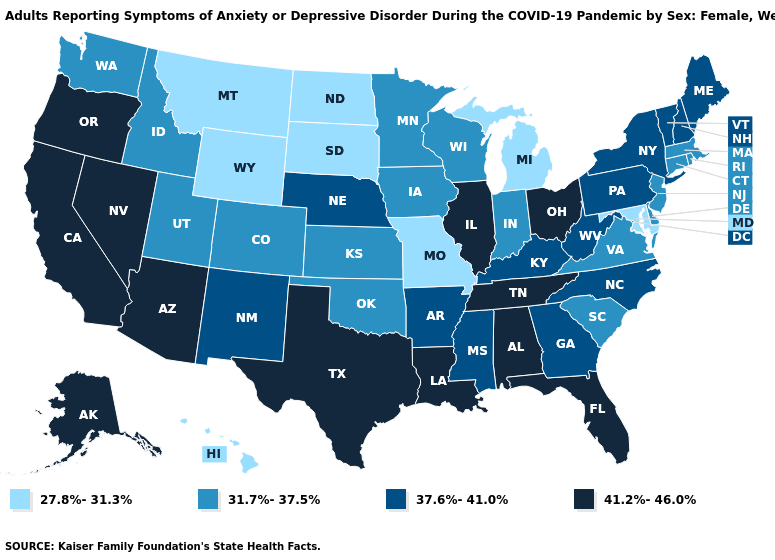Does the first symbol in the legend represent the smallest category?
Be succinct. Yes. Name the states that have a value in the range 41.2%-46.0%?
Short answer required. Alabama, Alaska, Arizona, California, Florida, Illinois, Louisiana, Nevada, Ohio, Oregon, Tennessee, Texas. Name the states that have a value in the range 27.8%-31.3%?
Give a very brief answer. Hawaii, Maryland, Michigan, Missouri, Montana, North Dakota, South Dakota, Wyoming. Which states have the lowest value in the USA?
Give a very brief answer. Hawaii, Maryland, Michigan, Missouri, Montana, North Dakota, South Dakota, Wyoming. What is the value of Illinois?
Keep it brief. 41.2%-46.0%. Name the states that have a value in the range 31.7%-37.5%?
Answer briefly. Colorado, Connecticut, Delaware, Idaho, Indiana, Iowa, Kansas, Massachusetts, Minnesota, New Jersey, Oklahoma, Rhode Island, South Carolina, Utah, Virginia, Washington, Wisconsin. Name the states that have a value in the range 27.8%-31.3%?
Short answer required. Hawaii, Maryland, Michigan, Missouri, Montana, North Dakota, South Dakota, Wyoming. What is the value of California?
Short answer required. 41.2%-46.0%. Name the states that have a value in the range 27.8%-31.3%?
Keep it brief. Hawaii, Maryland, Michigan, Missouri, Montana, North Dakota, South Dakota, Wyoming. Does the map have missing data?
Answer briefly. No. What is the value of North Dakota?
Keep it brief. 27.8%-31.3%. Does the first symbol in the legend represent the smallest category?
Keep it brief. Yes. What is the value of South Dakota?
Answer briefly. 27.8%-31.3%. What is the value of Georgia?
Short answer required. 37.6%-41.0%. What is the highest value in the Northeast ?
Short answer required. 37.6%-41.0%. 